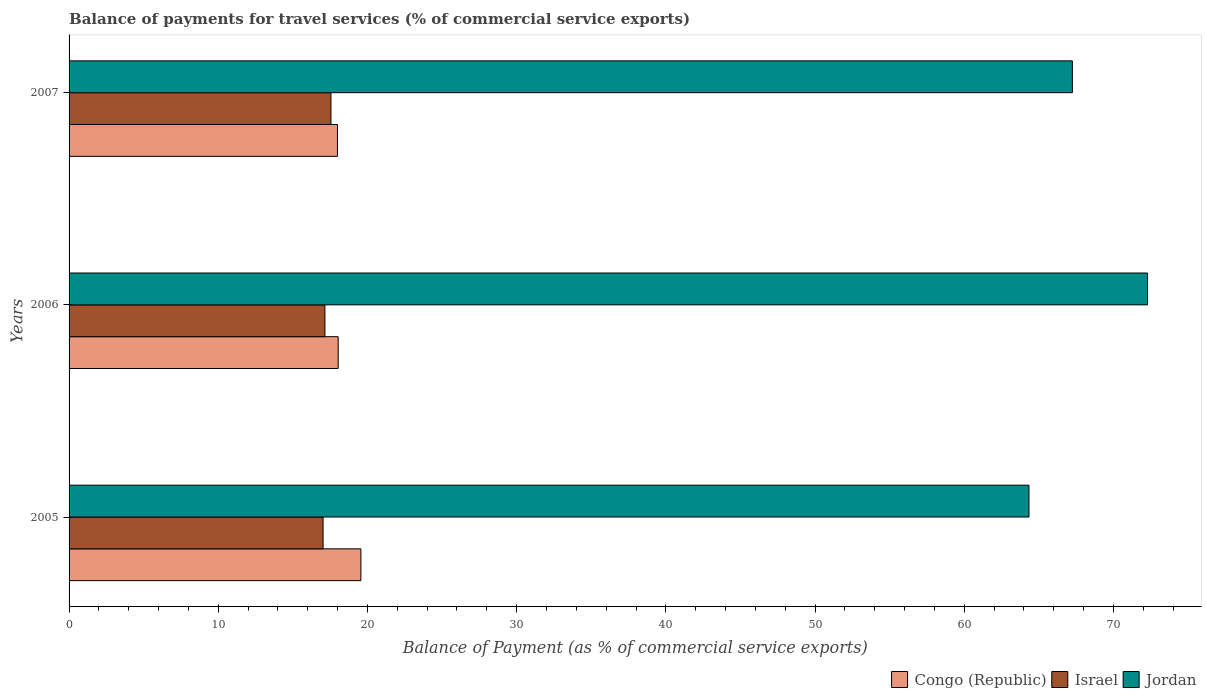How many bars are there on the 1st tick from the top?
Your response must be concise. 3. In how many cases, is the number of bars for a given year not equal to the number of legend labels?
Give a very brief answer. 0. What is the balance of payments for travel services in Jordan in 2006?
Ensure brevity in your answer.  72.29. Across all years, what is the maximum balance of payments for travel services in Congo (Republic)?
Ensure brevity in your answer.  19.56. Across all years, what is the minimum balance of payments for travel services in Jordan?
Make the answer very short. 64.34. In which year was the balance of payments for travel services in Congo (Republic) maximum?
Offer a terse response. 2005. What is the total balance of payments for travel services in Israel in the graph?
Make the answer very short. 51.73. What is the difference between the balance of payments for travel services in Congo (Republic) in 2005 and that in 2007?
Your answer should be compact. 1.57. What is the difference between the balance of payments for travel services in Jordan in 2006 and the balance of payments for travel services in Israel in 2005?
Offer a very short reply. 55.26. What is the average balance of payments for travel services in Israel per year?
Your response must be concise. 17.24. In the year 2006, what is the difference between the balance of payments for travel services in Jordan and balance of payments for travel services in Congo (Republic)?
Keep it short and to the point. 54.25. In how many years, is the balance of payments for travel services in Israel greater than 32 %?
Offer a terse response. 0. What is the ratio of the balance of payments for travel services in Congo (Republic) in 2006 to that in 2007?
Make the answer very short. 1. Is the difference between the balance of payments for travel services in Jordan in 2005 and 2007 greater than the difference between the balance of payments for travel services in Congo (Republic) in 2005 and 2007?
Provide a short and direct response. No. What is the difference between the highest and the second highest balance of payments for travel services in Jordan?
Your answer should be very brief. 5.04. What is the difference between the highest and the lowest balance of payments for travel services in Congo (Republic)?
Ensure brevity in your answer.  1.57. In how many years, is the balance of payments for travel services in Jordan greater than the average balance of payments for travel services in Jordan taken over all years?
Your answer should be very brief. 1. Is the sum of the balance of payments for travel services in Israel in 2005 and 2006 greater than the maximum balance of payments for travel services in Congo (Republic) across all years?
Provide a succinct answer. Yes. What does the 1st bar from the top in 2005 represents?
Provide a short and direct response. Jordan. What does the 2nd bar from the bottom in 2005 represents?
Offer a very short reply. Israel. Are all the bars in the graph horizontal?
Your answer should be compact. Yes. How many years are there in the graph?
Your answer should be very brief. 3. Does the graph contain any zero values?
Offer a very short reply. No. How many legend labels are there?
Offer a very short reply. 3. How are the legend labels stacked?
Give a very brief answer. Horizontal. What is the title of the graph?
Provide a short and direct response. Balance of payments for travel services (% of commercial service exports). What is the label or title of the X-axis?
Keep it short and to the point. Balance of Payment (as % of commercial service exports). What is the Balance of Payment (as % of commercial service exports) of Congo (Republic) in 2005?
Give a very brief answer. 19.56. What is the Balance of Payment (as % of commercial service exports) of Israel in 2005?
Offer a terse response. 17.02. What is the Balance of Payment (as % of commercial service exports) of Jordan in 2005?
Provide a short and direct response. 64.34. What is the Balance of Payment (as % of commercial service exports) in Congo (Republic) in 2006?
Provide a short and direct response. 18.04. What is the Balance of Payment (as % of commercial service exports) of Israel in 2006?
Make the answer very short. 17.15. What is the Balance of Payment (as % of commercial service exports) in Jordan in 2006?
Offer a very short reply. 72.29. What is the Balance of Payment (as % of commercial service exports) of Congo (Republic) in 2007?
Make the answer very short. 17.99. What is the Balance of Payment (as % of commercial service exports) of Israel in 2007?
Your answer should be very brief. 17.55. What is the Balance of Payment (as % of commercial service exports) of Jordan in 2007?
Provide a succinct answer. 67.25. Across all years, what is the maximum Balance of Payment (as % of commercial service exports) in Congo (Republic)?
Make the answer very short. 19.56. Across all years, what is the maximum Balance of Payment (as % of commercial service exports) of Israel?
Keep it short and to the point. 17.55. Across all years, what is the maximum Balance of Payment (as % of commercial service exports) of Jordan?
Your response must be concise. 72.29. Across all years, what is the minimum Balance of Payment (as % of commercial service exports) of Congo (Republic)?
Offer a very short reply. 17.99. Across all years, what is the minimum Balance of Payment (as % of commercial service exports) of Israel?
Offer a very short reply. 17.02. Across all years, what is the minimum Balance of Payment (as % of commercial service exports) in Jordan?
Provide a succinct answer. 64.34. What is the total Balance of Payment (as % of commercial service exports) in Congo (Republic) in the graph?
Keep it short and to the point. 55.58. What is the total Balance of Payment (as % of commercial service exports) of Israel in the graph?
Your response must be concise. 51.73. What is the total Balance of Payment (as % of commercial service exports) of Jordan in the graph?
Your response must be concise. 203.88. What is the difference between the Balance of Payment (as % of commercial service exports) in Congo (Republic) in 2005 and that in 2006?
Ensure brevity in your answer.  1.52. What is the difference between the Balance of Payment (as % of commercial service exports) of Israel in 2005 and that in 2006?
Offer a terse response. -0.12. What is the difference between the Balance of Payment (as % of commercial service exports) in Jordan in 2005 and that in 2006?
Your response must be concise. -7.95. What is the difference between the Balance of Payment (as % of commercial service exports) of Congo (Republic) in 2005 and that in 2007?
Provide a succinct answer. 1.57. What is the difference between the Balance of Payment (as % of commercial service exports) in Israel in 2005 and that in 2007?
Offer a very short reply. -0.53. What is the difference between the Balance of Payment (as % of commercial service exports) in Jordan in 2005 and that in 2007?
Give a very brief answer. -2.91. What is the difference between the Balance of Payment (as % of commercial service exports) of Congo (Republic) in 2006 and that in 2007?
Your answer should be very brief. 0.05. What is the difference between the Balance of Payment (as % of commercial service exports) in Israel in 2006 and that in 2007?
Provide a short and direct response. -0.41. What is the difference between the Balance of Payment (as % of commercial service exports) in Jordan in 2006 and that in 2007?
Give a very brief answer. 5.04. What is the difference between the Balance of Payment (as % of commercial service exports) of Congo (Republic) in 2005 and the Balance of Payment (as % of commercial service exports) of Israel in 2006?
Make the answer very short. 2.41. What is the difference between the Balance of Payment (as % of commercial service exports) in Congo (Republic) in 2005 and the Balance of Payment (as % of commercial service exports) in Jordan in 2006?
Keep it short and to the point. -52.73. What is the difference between the Balance of Payment (as % of commercial service exports) of Israel in 2005 and the Balance of Payment (as % of commercial service exports) of Jordan in 2006?
Offer a very short reply. -55.26. What is the difference between the Balance of Payment (as % of commercial service exports) in Congo (Republic) in 2005 and the Balance of Payment (as % of commercial service exports) in Israel in 2007?
Keep it short and to the point. 2.01. What is the difference between the Balance of Payment (as % of commercial service exports) in Congo (Republic) in 2005 and the Balance of Payment (as % of commercial service exports) in Jordan in 2007?
Make the answer very short. -47.69. What is the difference between the Balance of Payment (as % of commercial service exports) in Israel in 2005 and the Balance of Payment (as % of commercial service exports) in Jordan in 2007?
Keep it short and to the point. -50.22. What is the difference between the Balance of Payment (as % of commercial service exports) of Congo (Republic) in 2006 and the Balance of Payment (as % of commercial service exports) of Israel in 2007?
Your answer should be compact. 0.48. What is the difference between the Balance of Payment (as % of commercial service exports) in Congo (Republic) in 2006 and the Balance of Payment (as % of commercial service exports) in Jordan in 2007?
Your answer should be compact. -49.21. What is the difference between the Balance of Payment (as % of commercial service exports) in Israel in 2006 and the Balance of Payment (as % of commercial service exports) in Jordan in 2007?
Offer a very short reply. -50.1. What is the average Balance of Payment (as % of commercial service exports) in Congo (Republic) per year?
Your answer should be very brief. 18.53. What is the average Balance of Payment (as % of commercial service exports) of Israel per year?
Keep it short and to the point. 17.24. What is the average Balance of Payment (as % of commercial service exports) of Jordan per year?
Your answer should be very brief. 67.96. In the year 2005, what is the difference between the Balance of Payment (as % of commercial service exports) in Congo (Republic) and Balance of Payment (as % of commercial service exports) in Israel?
Give a very brief answer. 2.53. In the year 2005, what is the difference between the Balance of Payment (as % of commercial service exports) in Congo (Republic) and Balance of Payment (as % of commercial service exports) in Jordan?
Provide a short and direct response. -44.78. In the year 2005, what is the difference between the Balance of Payment (as % of commercial service exports) of Israel and Balance of Payment (as % of commercial service exports) of Jordan?
Your answer should be compact. -47.32. In the year 2006, what is the difference between the Balance of Payment (as % of commercial service exports) in Congo (Republic) and Balance of Payment (as % of commercial service exports) in Israel?
Provide a short and direct response. 0.89. In the year 2006, what is the difference between the Balance of Payment (as % of commercial service exports) in Congo (Republic) and Balance of Payment (as % of commercial service exports) in Jordan?
Make the answer very short. -54.25. In the year 2006, what is the difference between the Balance of Payment (as % of commercial service exports) in Israel and Balance of Payment (as % of commercial service exports) in Jordan?
Your answer should be very brief. -55.14. In the year 2007, what is the difference between the Balance of Payment (as % of commercial service exports) in Congo (Republic) and Balance of Payment (as % of commercial service exports) in Israel?
Provide a short and direct response. 0.43. In the year 2007, what is the difference between the Balance of Payment (as % of commercial service exports) in Congo (Republic) and Balance of Payment (as % of commercial service exports) in Jordan?
Provide a short and direct response. -49.26. In the year 2007, what is the difference between the Balance of Payment (as % of commercial service exports) in Israel and Balance of Payment (as % of commercial service exports) in Jordan?
Provide a succinct answer. -49.69. What is the ratio of the Balance of Payment (as % of commercial service exports) of Congo (Republic) in 2005 to that in 2006?
Your answer should be very brief. 1.08. What is the ratio of the Balance of Payment (as % of commercial service exports) of Jordan in 2005 to that in 2006?
Give a very brief answer. 0.89. What is the ratio of the Balance of Payment (as % of commercial service exports) of Congo (Republic) in 2005 to that in 2007?
Provide a short and direct response. 1.09. What is the ratio of the Balance of Payment (as % of commercial service exports) in Israel in 2005 to that in 2007?
Make the answer very short. 0.97. What is the ratio of the Balance of Payment (as % of commercial service exports) of Jordan in 2005 to that in 2007?
Your response must be concise. 0.96. What is the ratio of the Balance of Payment (as % of commercial service exports) of Congo (Republic) in 2006 to that in 2007?
Offer a terse response. 1. What is the ratio of the Balance of Payment (as % of commercial service exports) in Israel in 2006 to that in 2007?
Provide a succinct answer. 0.98. What is the ratio of the Balance of Payment (as % of commercial service exports) of Jordan in 2006 to that in 2007?
Give a very brief answer. 1.07. What is the difference between the highest and the second highest Balance of Payment (as % of commercial service exports) of Congo (Republic)?
Provide a succinct answer. 1.52. What is the difference between the highest and the second highest Balance of Payment (as % of commercial service exports) in Israel?
Your answer should be very brief. 0.41. What is the difference between the highest and the second highest Balance of Payment (as % of commercial service exports) of Jordan?
Provide a short and direct response. 5.04. What is the difference between the highest and the lowest Balance of Payment (as % of commercial service exports) of Congo (Republic)?
Give a very brief answer. 1.57. What is the difference between the highest and the lowest Balance of Payment (as % of commercial service exports) of Israel?
Make the answer very short. 0.53. What is the difference between the highest and the lowest Balance of Payment (as % of commercial service exports) of Jordan?
Give a very brief answer. 7.95. 